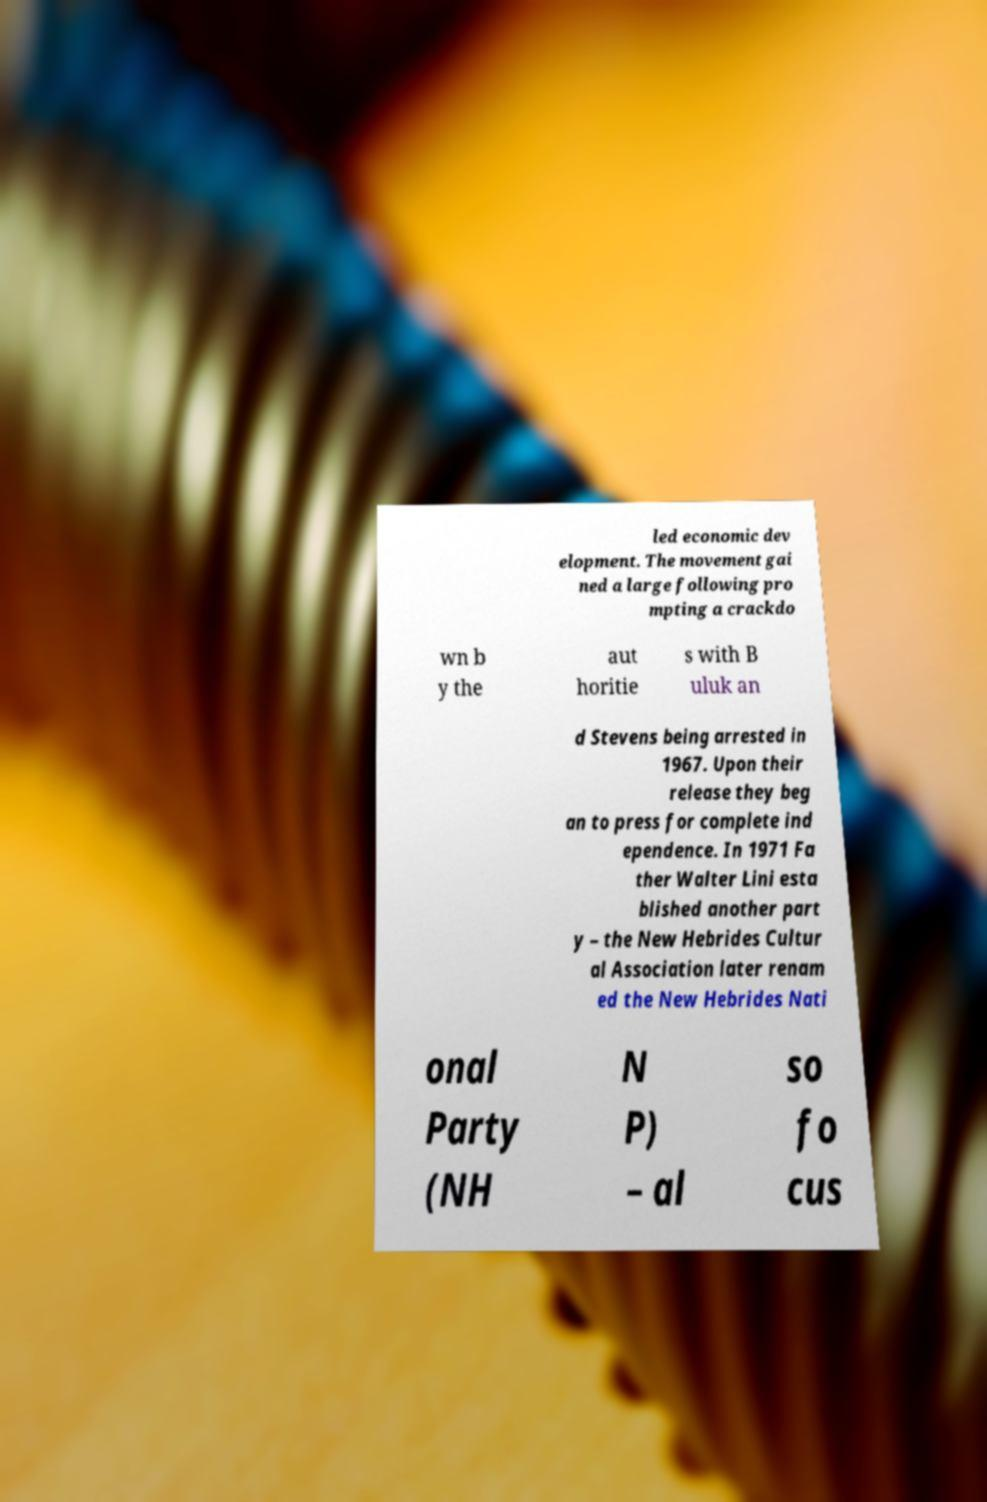Could you extract and type out the text from this image? led economic dev elopment. The movement gai ned a large following pro mpting a crackdo wn b y the aut horitie s with B uluk an d Stevens being arrested in 1967. Upon their release they beg an to press for complete ind ependence. In 1971 Fa ther Walter Lini esta blished another part y – the New Hebrides Cultur al Association later renam ed the New Hebrides Nati onal Party (NH N P) – al so fo cus 